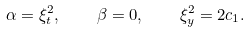<formula> <loc_0><loc_0><loc_500><loc_500>\alpha = \xi _ { t } ^ { 2 } , \quad \beta = 0 , \quad \xi _ { y } ^ { 2 } = 2 c _ { 1 } .</formula> 